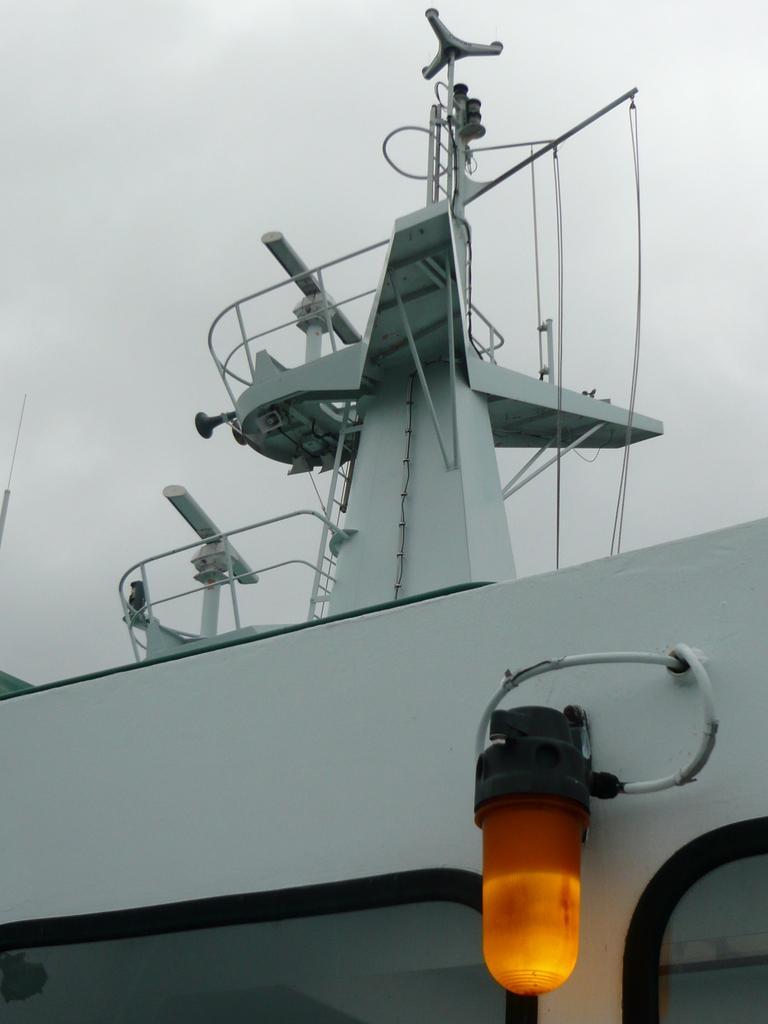In one or two sentences, can you explain what this image depicts? In this image I can see a light in the front. There are wires and white fences above it. It looks like a ship and there is sky at the top. 